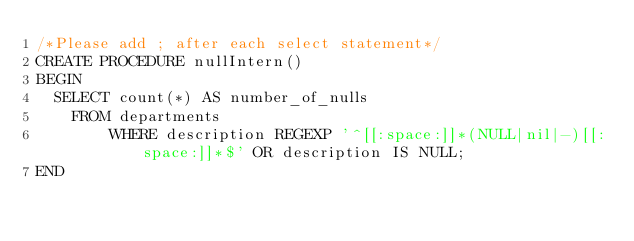Convert code to text. <code><loc_0><loc_0><loc_500><loc_500><_SQL_>/*Please add ; after each select statement*/
CREATE PROCEDURE nullIntern()
BEGIN
	SELECT count(*) AS number_of_nulls
    FROM departments
        WHERE description REGEXP '^[[:space:]]*(NULL|nil|-)[[:space:]]*$' OR description IS NULL;
END</code> 